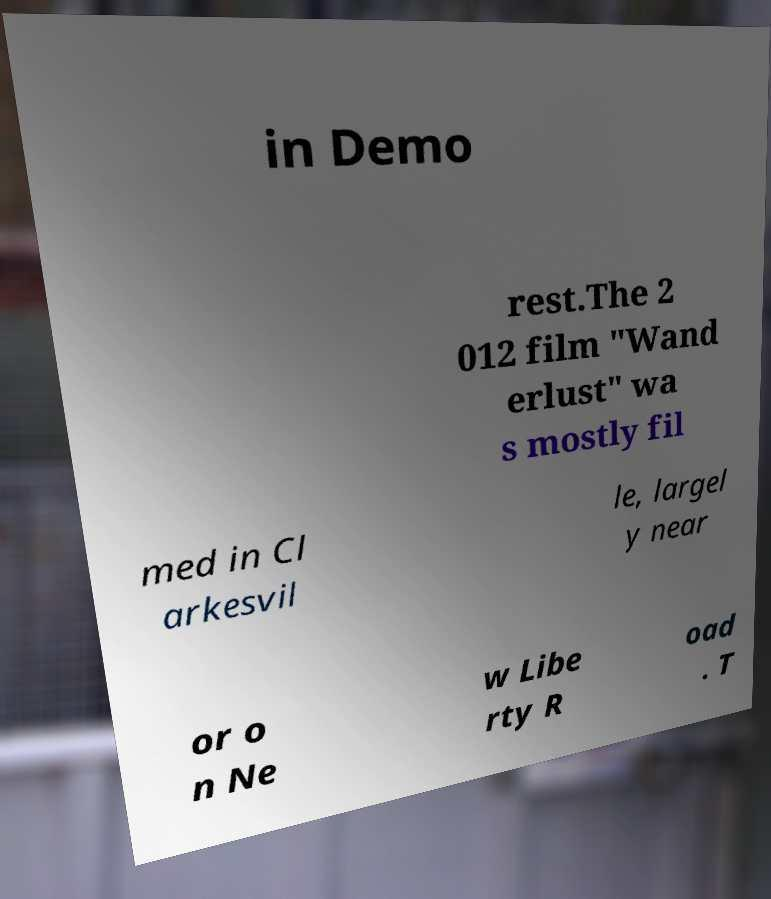There's text embedded in this image that I need extracted. Can you transcribe it verbatim? in Demo rest.The 2 012 film "Wand erlust" wa s mostly fil med in Cl arkesvil le, largel y near or o n Ne w Libe rty R oad . T 